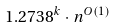Convert formula to latex. <formula><loc_0><loc_0><loc_500><loc_500>1 . 2 7 3 8 ^ { k } \cdot n ^ { O ( 1 ) }</formula> 